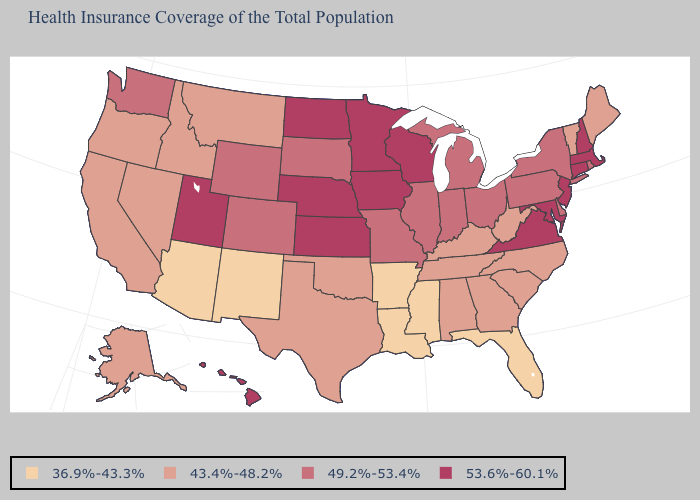Is the legend a continuous bar?
Give a very brief answer. No. Does the map have missing data?
Be succinct. No. What is the value of North Carolina?
Short answer required. 43.4%-48.2%. What is the value of Arizona?
Quick response, please. 36.9%-43.3%. Does Michigan have a lower value than New Hampshire?
Quick response, please. Yes. What is the highest value in the USA?
Answer briefly. 53.6%-60.1%. What is the value of Utah?
Short answer required. 53.6%-60.1%. Does Ohio have the lowest value in the USA?
Give a very brief answer. No. Name the states that have a value in the range 49.2%-53.4%?
Be succinct. Colorado, Delaware, Illinois, Indiana, Michigan, Missouri, New York, Ohio, Pennsylvania, Rhode Island, South Dakota, Washington, Wyoming. What is the value of New Mexico?
Give a very brief answer. 36.9%-43.3%. Does Kentucky have the lowest value in the South?
Write a very short answer. No. What is the value of California?
Short answer required. 43.4%-48.2%. What is the lowest value in states that border Kentucky?
Concise answer only. 43.4%-48.2%. Name the states that have a value in the range 49.2%-53.4%?
Answer briefly. Colorado, Delaware, Illinois, Indiana, Michigan, Missouri, New York, Ohio, Pennsylvania, Rhode Island, South Dakota, Washington, Wyoming. Name the states that have a value in the range 53.6%-60.1%?
Be succinct. Connecticut, Hawaii, Iowa, Kansas, Maryland, Massachusetts, Minnesota, Nebraska, New Hampshire, New Jersey, North Dakota, Utah, Virginia, Wisconsin. 